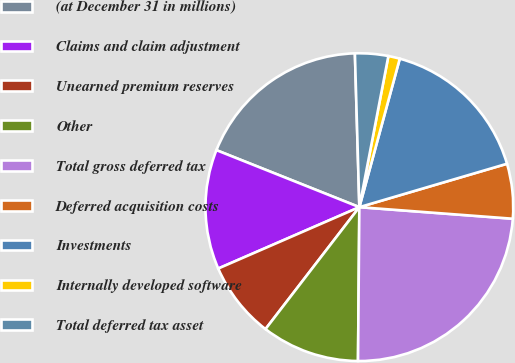Convert chart. <chart><loc_0><loc_0><loc_500><loc_500><pie_chart><fcel>(at December 31 in millions)<fcel>Claims and claim adjustment<fcel>Unearned premium reserves<fcel>Other<fcel>Total gross deferred tax<fcel>Deferred acquisition costs<fcel>Investments<fcel>Internally developed software<fcel>Total deferred tax asset<nl><fcel>18.5%<fcel>12.57%<fcel>8.03%<fcel>10.3%<fcel>23.94%<fcel>5.75%<fcel>16.22%<fcel>1.21%<fcel>3.48%<nl></chart> 